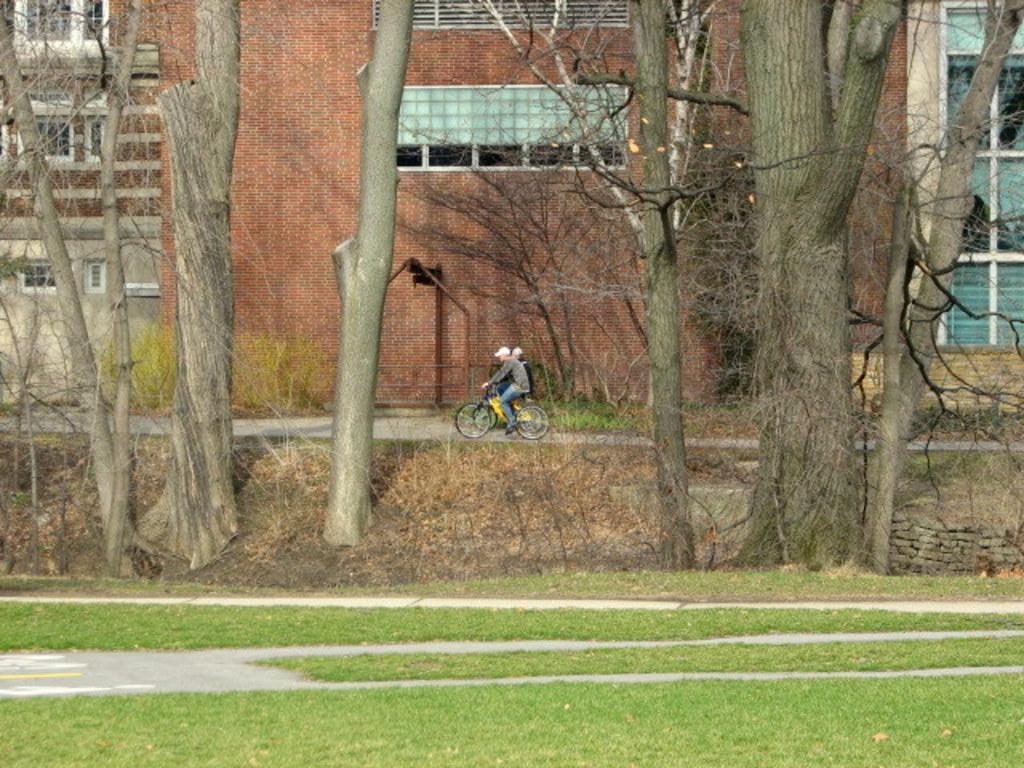Can you describe this image briefly? Here we can see grass and trees and there are two people sitting and riding bicycles. Background we can see building and wall. 